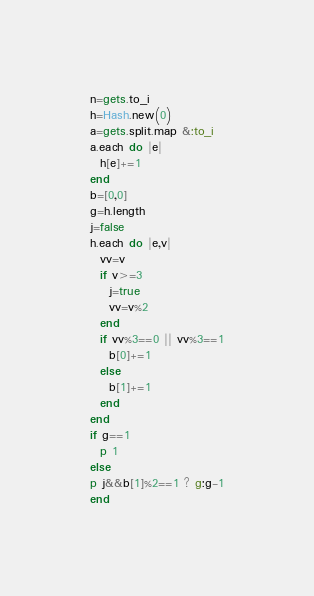<code> <loc_0><loc_0><loc_500><loc_500><_Ruby_>n=gets.to_i
h=Hash.new(0)
a=gets.split.map &:to_i
a.each do |e|
  h[e]+=1
end
b=[0,0]
g=h.length
j=false
h.each do |e,v|
  vv=v
  if v>=3
    j=true
    vv=v%2
  end
  if vv%3==0 || vv%3==1
    b[0]+=1
  else
    b[1]+=1
  end
end
if g==1
  p 1
else
p j&&b[1]%2==1 ? g:g-1
end</code> 